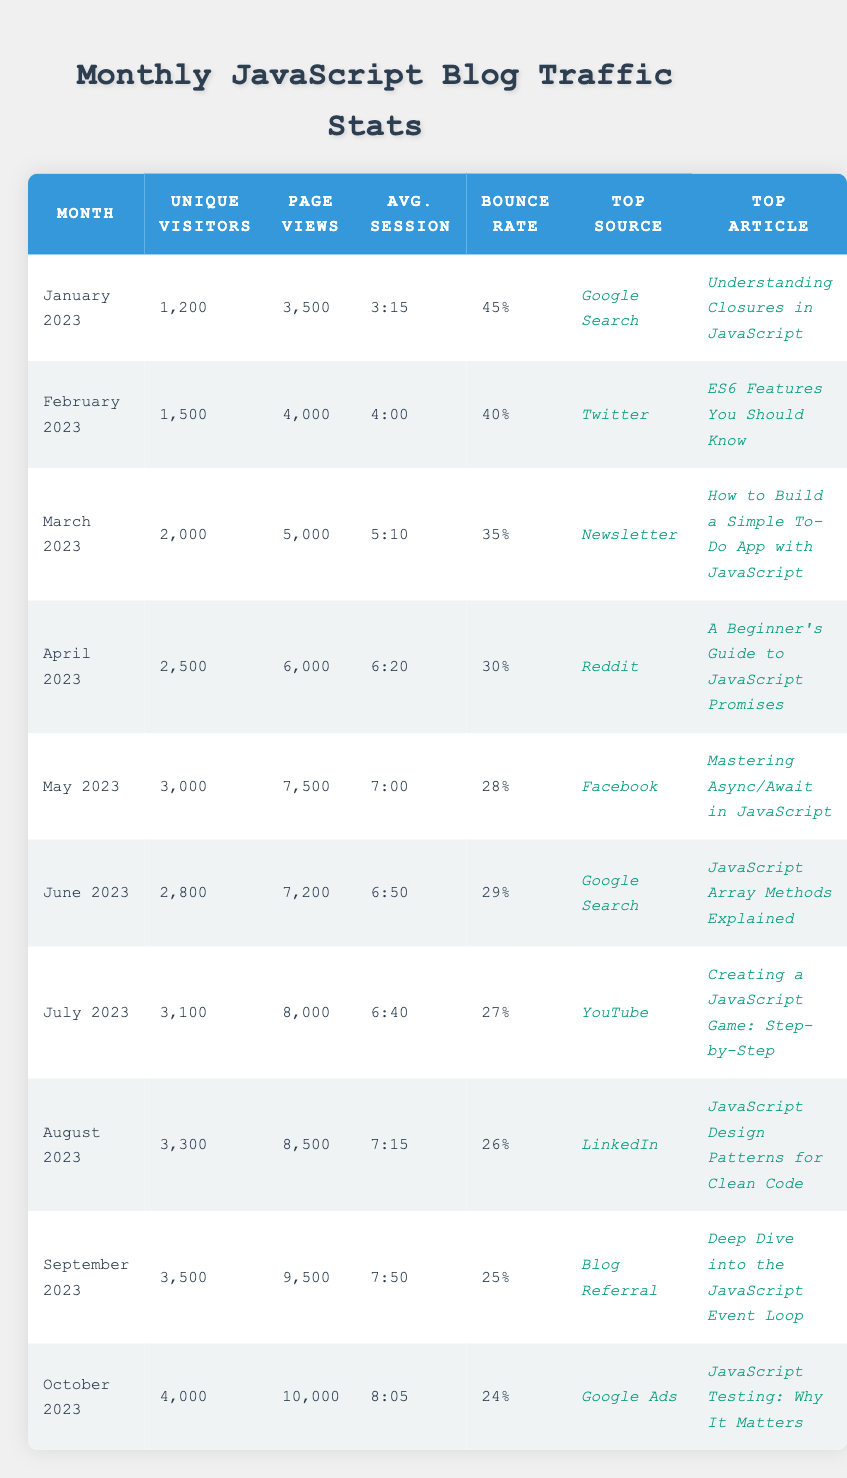What was the top article in March 2023? The table lists the top articles for each month, and for March 2023, the entry shows that the top article was "How to Build a Simple To-Do App with JavaScript."
Answer: How to Build a Simple To-Do App with JavaScript How many unique visitors did the blog receive in August 2023? Referring to the August 2023 row in the table, the number of unique visitors listed is 3,300.
Answer: 3,300 What is the average bounce rate for the first half of the year (January to June 2023)? To find the average bounce rate for January to June, we need to sum their bounce rates: (45% + 40% + 35% + 30% + 28% + 29%) = 207%. Then, divide this by 6 (the number of months), so 207% / 6 = 34.5%.
Answer: 34.5% Did the blog have more unique visitors in April or May 2023? Looking at the unique visitors for April 2023 (2,500) compared to May 2023 (3,000), May had more unique visitors than April.
Answer: Yes, May had more visitors Which month saw the highest average session duration? The highest average session duration can be found by reviewing each month's data. The entries indicate that October 2023 has the highest session duration of 8:05.
Answer: October 2023 What was the change in unique visitors from April to October 2023? To find the change in unique visitors, we subtract the number of unique visitors in April (2,500) from those in October (4,000): 4,000 - 2,500 = 1,500.
Answer: 1,500 Which top source had the highest number of visitors in a single month, and what month was it? Reviewing the top sources for each month, Google Ads brought in the highest number of unique visitors in October 2023, with 4,000 unique visitors.
Answer: Google Ads in October 2023 What is the overall growth in page views from January to October 2023? The number of page views in January 2023 is 3,500 and in October 2023 it is 10,000. The growth is calculated as: 10,000 - 3,500 = 6,500.
Answer: 6,500 Was the top article in September 2023 related to JavaScript promises? Checking the top article for September 2023 shows "Deep Dive into the JavaScript Event Loop," which is not related to promises. Therefore, the answer is no.
Answer: No What is the trend in bounce rates from January to October 2023? By checking each month's bounce rate, we see it decreased from 45% in January to 24% in October. This indicates a downward trend over the months.
Answer: Decreasing trend 